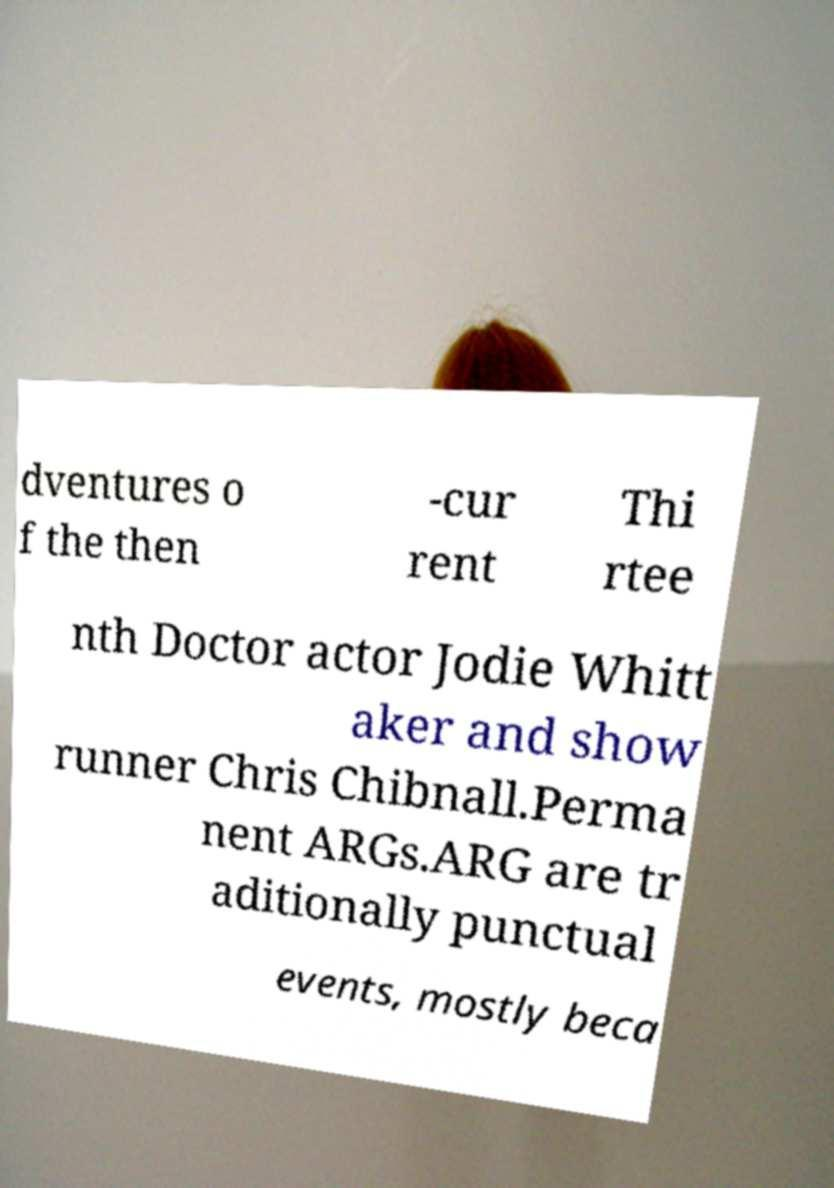What messages or text are displayed in this image? I need them in a readable, typed format. dventures o f the then -cur rent Thi rtee nth Doctor actor Jodie Whitt aker and show runner Chris Chibnall.Perma nent ARGs.ARG are tr aditionally punctual events, mostly beca 